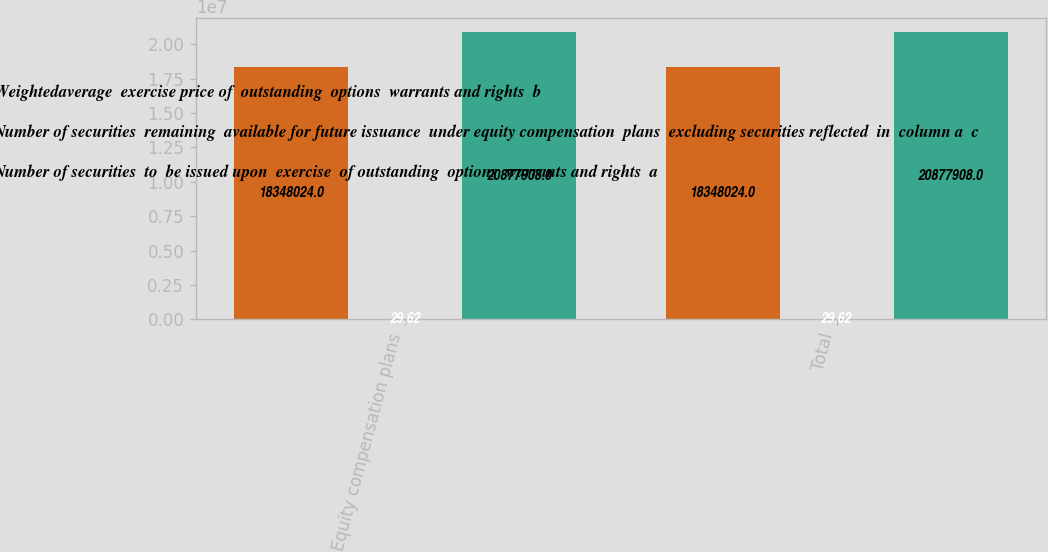<chart> <loc_0><loc_0><loc_500><loc_500><stacked_bar_chart><ecel><fcel>Equity compensation plans<fcel>Total<nl><fcel>Weightedaverage  exercise price of  outstanding  options  warrants and rights  b<fcel>1.8348e+07<fcel>1.8348e+07<nl><fcel>Number of securities  remaining  available for future issuance  under equity compensation  plans  excluding securities reflected  in  column a  c<fcel>29.62<fcel>29.62<nl><fcel>Number of securities  to  be issued upon  exercise  of outstanding  options  warrants and rights  a<fcel>2.08779e+07<fcel>2.08779e+07<nl></chart> 